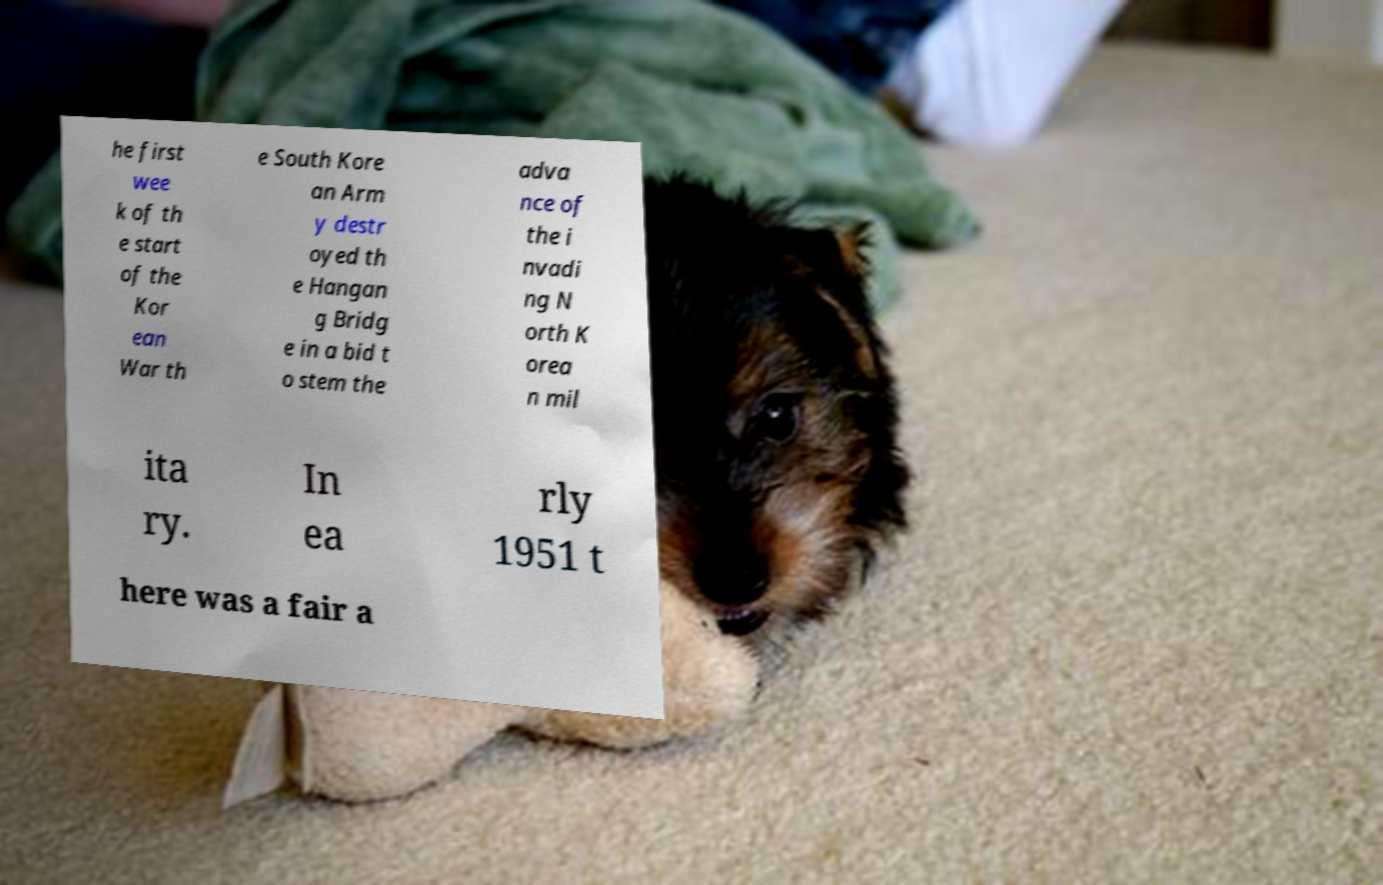Can you read and provide the text displayed in the image?This photo seems to have some interesting text. Can you extract and type it out for me? he first wee k of th e start of the Kor ean War th e South Kore an Arm y destr oyed th e Hangan g Bridg e in a bid t o stem the adva nce of the i nvadi ng N orth K orea n mil ita ry. In ea rly 1951 t here was a fair a 